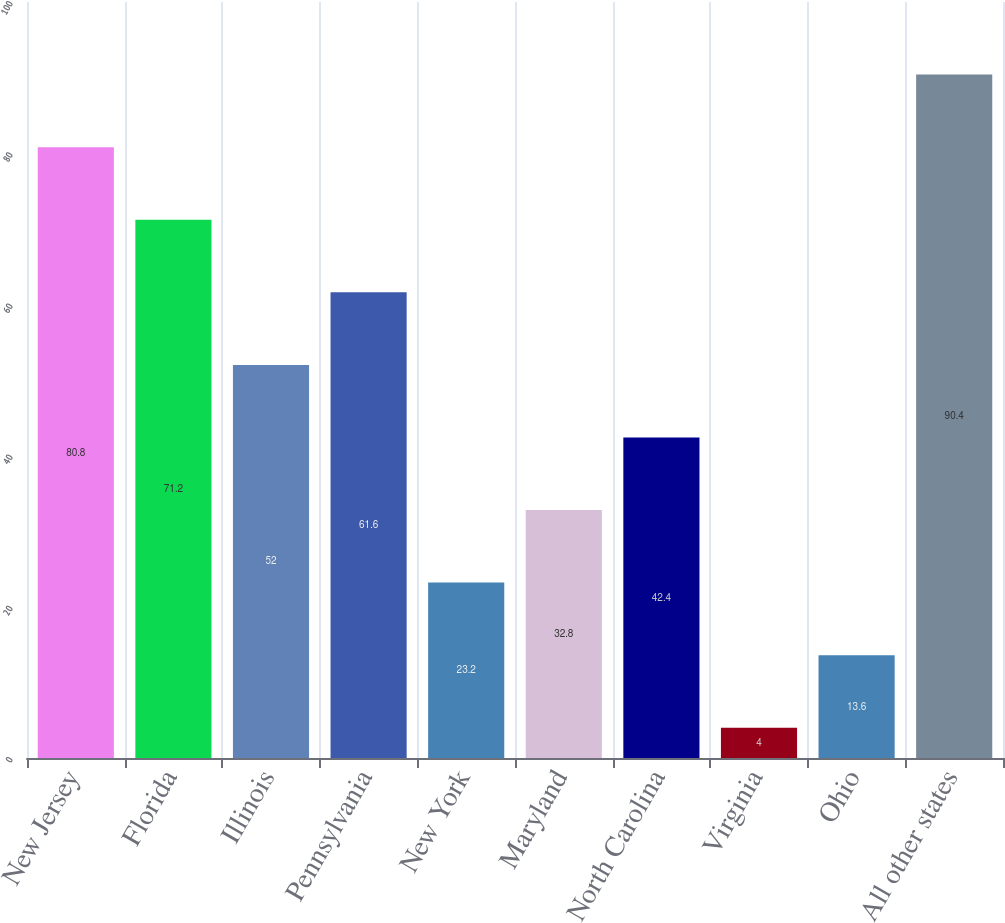Convert chart. <chart><loc_0><loc_0><loc_500><loc_500><bar_chart><fcel>New Jersey<fcel>Florida<fcel>Illinois<fcel>Pennsylvania<fcel>New York<fcel>Maryland<fcel>North Carolina<fcel>Virginia<fcel>Ohio<fcel>All other states<nl><fcel>80.8<fcel>71.2<fcel>52<fcel>61.6<fcel>23.2<fcel>32.8<fcel>42.4<fcel>4<fcel>13.6<fcel>90.4<nl></chart> 